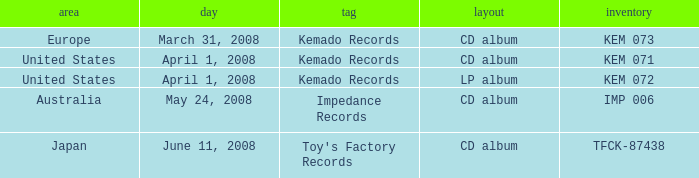Which Label has a Region of united states, and a Format of lp album? Kemado Records. 